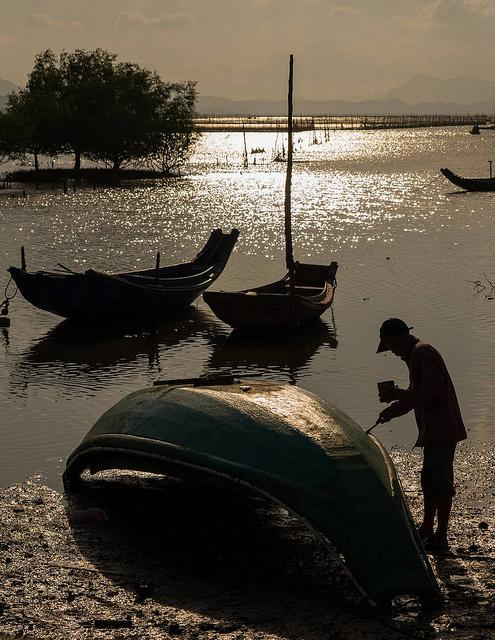What is the goal of the man working on the boat here? painting 